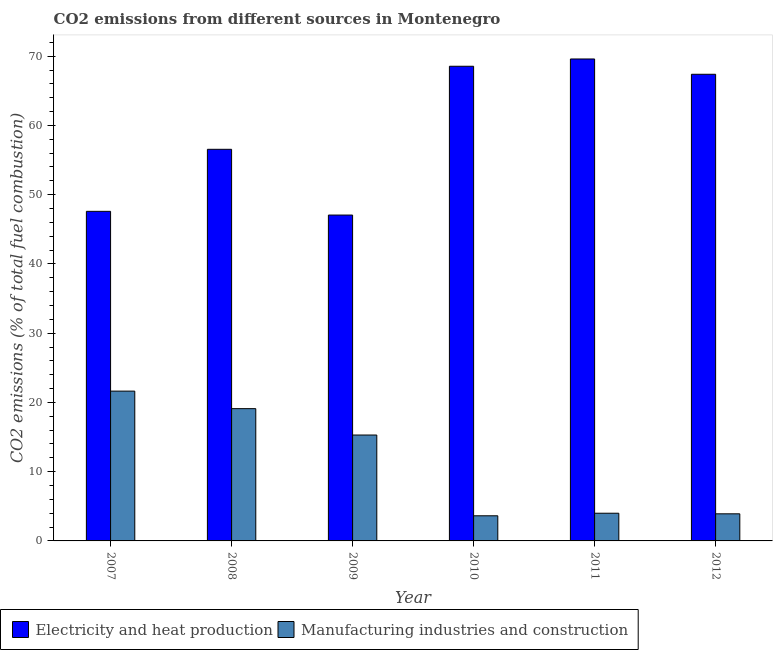How many different coloured bars are there?
Your answer should be compact. 2. How many groups of bars are there?
Provide a succinct answer. 6. What is the co2 emissions due to electricity and heat production in 2009?
Provide a short and direct response. 47.06. Across all years, what is the maximum co2 emissions due to electricity and heat production?
Give a very brief answer. 69.6. Across all years, what is the minimum co2 emissions due to manufacturing industries?
Offer a terse response. 3.63. In which year was the co2 emissions due to electricity and heat production minimum?
Your answer should be very brief. 2009. What is the total co2 emissions due to electricity and heat production in the graph?
Provide a short and direct response. 356.75. What is the difference between the co2 emissions due to electricity and heat production in 2008 and that in 2010?
Your response must be concise. -11.99. What is the difference between the co2 emissions due to manufacturing industries in 2012 and the co2 emissions due to electricity and heat production in 2007?
Give a very brief answer. -17.72. What is the average co2 emissions due to manufacturing industries per year?
Offer a very short reply. 11.26. What is the ratio of the co2 emissions due to manufacturing industries in 2010 to that in 2011?
Give a very brief answer. 0.91. Is the difference between the co2 emissions due to electricity and heat production in 2007 and 2010 greater than the difference between the co2 emissions due to manufacturing industries in 2007 and 2010?
Provide a succinct answer. No. What is the difference between the highest and the second highest co2 emissions due to electricity and heat production?
Make the answer very short. 1.05. What is the difference between the highest and the lowest co2 emissions due to manufacturing industries?
Ensure brevity in your answer.  18.01. In how many years, is the co2 emissions due to electricity and heat production greater than the average co2 emissions due to electricity and heat production taken over all years?
Offer a very short reply. 3. What does the 1st bar from the left in 2011 represents?
Provide a succinct answer. Electricity and heat production. What does the 2nd bar from the right in 2012 represents?
Your answer should be very brief. Electricity and heat production. How many years are there in the graph?
Your response must be concise. 6. What is the difference between two consecutive major ticks on the Y-axis?
Provide a short and direct response. 10. Does the graph contain any zero values?
Make the answer very short. No. Does the graph contain grids?
Offer a very short reply. No. What is the title of the graph?
Your answer should be compact. CO2 emissions from different sources in Montenegro. Does "Quality of trade" appear as one of the legend labels in the graph?
Give a very brief answer. No. What is the label or title of the Y-axis?
Ensure brevity in your answer.  CO2 emissions (% of total fuel combustion). What is the CO2 emissions (% of total fuel combustion) of Electricity and heat production in 2007?
Ensure brevity in your answer.  47.6. What is the CO2 emissions (% of total fuel combustion) of Manufacturing industries and construction in 2007?
Keep it short and to the point. 21.63. What is the CO2 emissions (% of total fuel combustion) in Electricity and heat production in 2008?
Make the answer very short. 56.55. What is the CO2 emissions (% of total fuel combustion) in Manufacturing industries and construction in 2008?
Provide a short and direct response. 19.1. What is the CO2 emissions (% of total fuel combustion) in Electricity and heat production in 2009?
Your answer should be very brief. 47.06. What is the CO2 emissions (% of total fuel combustion) of Manufacturing industries and construction in 2009?
Your answer should be compact. 15.29. What is the CO2 emissions (% of total fuel combustion) of Electricity and heat production in 2010?
Your answer should be very brief. 68.55. What is the CO2 emissions (% of total fuel combustion) of Manufacturing industries and construction in 2010?
Your answer should be very brief. 3.63. What is the CO2 emissions (% of total fuel combustion) in Electricity and heat production in 2011?
Your answer should be very brief. 69.6. What is the CO2 emissions (% of total fuel combustion) of Electricity and heat production in 2012?
Your response must be concise. 67.39. What is the CO2 emissions (% of total fuel combustion) in Manufacturing industries and construction in 2012?
Your answer should be compact. 3.91. Across all years, what is the maximum CO2 emissions (% of total fuel combustion) in Electricity and heat production?
Provide a succinct answer. 69.6. Across all years, what is the maximum CO2 emissions (% of total fuel combustion) of Manufacturing industries and construction?
Your answer should be compact. 21.63. Across all years, what is the minimum CO2 emissions (% of total fuel combustion) in Electricity and heat production?
Make the answer very short. 47.06. Across all years, what is the minimum CO2 emissions (% of total fuel combustion) of Manufacturing industries and construction?
Your answer should be compact. 3.63. What is the total CO2 emissions (% of total fuel combustion) of Electricity and heat production in the graph?
Your response must be concise. 356.75. What is the total CO2 emissions (% of total fuel combustion) of Manufacturing industries and construction in the graph?
Give a very brief answer. 67.57. What is the difference between the CO2 emissions (% of total fuel combustion) in Electricity and heat production in 2007 and that in 2008?
Provide a succinct answer. -8.96. What is the difference between the CO2 emissions (% of total fuel combustion) of Manufacturing industries and construction in 2007 and that in 2008?
Your answer should be compact. 2.53. What is the difference between the CO2 emissions (% of total fuel combustion) of Electricity and heat production in 2007 and that in 2009?
Make the answer very short. 0.54. What is the difference between the CO2 emissions (% of total fuel combustion) of Manufacturing industries and construction in 2007 and that in 2009?
Keep it short and to the point. 6.34. What is the difference between the CO2 emissions (% of total fuel combustion) in Electricity and heat production in 2007 and that in 2010?
Provide a short and direct response. -20.95. What is the difference between the CO2 emissions (% of total fuel combustion) of Manufacturing industries and construction in 2007 and that in 2010?
Your response must be concise. 18.01. What is the difference between the CO2 emissions (% of total fuel combustion) of Electricity and heat production in 2007 and that in 2011?
Offer a very short reply. -22. What is the difference between the CO2 emissions (% of total fuel combustion) of Manufacturing industries and construction in 2007 and that in 2011?
Make the answer very short. 17.63. What is the difference between the CO2 emissions (% of total fuel combustion) of Electricity and heat production in 2007 and that in 2012?
Your response must be concise. -19.8. What is the difference between the CO2 emissions (% of total fuel combustion) of Manufacturing industries and construction in 2007 and that in 2012?
Provide a succinct answer. 17.72. What is the difference between the CO2 emissions (% of total fuel combustion) in Electricity and heat production in 2008 and that in 2009?
Offer a terse response. 9.5. What is the difference between the CO2 emissions (% of total fuel combustion) in Manufacturing industries and construction in 2008 and that in 2009?
Your response must be concise. 3.81. What is the difference between the CO2 emissions (% of total fuel combustion) of Electricity and heat production in 2008 and that in 2010?
Your response must be concise. -11.99. What is the difference between the CO2 emissions (% of total fuel combustion) of Manufacturing industries and construction in 2008 and that in 2010?
Offer a terse response. 15.47. What is the difference between the CO2 emissions (% of total fuel combustion) of Electricity and heat production in 2008 and that in 2011?
Your answer should be very brief. -13.05. What is the difference between the CO2 emissions (% of total fuel combustion) in Manufacturing industries and construction in 2008 and that in 2011?
Offer a very short reply. 15.1. What is the difference between the CO2 emissions (% of total fuel combustion) in Electricity and heat production in 2008 and that in 2012?
Your answer should be very brief. -10.84. What is the difference between the CO2 emissions (% of total fuel combustion) in Manufacturing industries and construction in 2008 and that in 2012?
Offer a terse response. 15.19. What is the difference between the CO2 emissions (% of total fuel combustion) in Electricity and heat production in 2009 and that in 2010?
Offer a very short reply. -21.49. What is the difference between the CO2 emissions (% of total fuel combustion) of Manufacturing industries and construction in 2009 and that in 2010?
Offer a terse response. 11.67. What is the difference between the CO2 emissions (% of total fuel combustion) in Electricity and heat production in 2009 and that in 2011?
Give a very brief answer. -22.54. What is the difference between the CO2 emissions (% of total fuel combustion) of Manufacturing industries and construction in 2009 and that in 2011?
Your response must be concise. 11.29. What is the difference between the CO2 emissions (% of total fuel combustion) in Electricity and heat production in 2009 and that in 2012?
Provide a short and direct response. -20.33. What is the difference between the CO2 emissions (% of total fuel combustion) in Manufacturing industries and construction in 2009 and that in 2012?
Provide a short and direct response. 11.38. What is the difference between the CO2 emissions (% of total fuel combustion) of Electricity and heat production in 2010 and that in 2011?
Offer a terse response. -1.05. What is the difference between the CO2 emissions (% of total fuel combustion) in Manufacturing industries and construction in 2010 and that in 2011?
Your response must be concise. -0.37. What is the difference between the CO2 emissions (% of total fuel combustion) in Electricity and heat production in 2010 and that in 2012?
Your response must be concise. 1.16. What is the difference between the CO2 emissions (% of total fuel combustion) of Manufacturing industries and construction in 2010 and that in 2012?
Offer a very short reply. -0.28. What is the difference between the CO2 emissions (% of total fuel combustion) in Electricity and heat production in 2011 and that in 2012?
Make the answer very short. 2.21. What is the difference between the CO2 emissions (% of total fuel combustion) of Manufacturing industries and construction in 2011 and that in 2012?
Provide a succinct answer. 0.09. What is the difference between the CO2 emissions (% of total fuel combustion) of Electricity and heat production in 2007 and the CO2 emissions (% of total fuel combustion) of Manufacturing industries and construction in 2008?
Your answer should be compact. 28.5. What is the difference between the CO2 emissions (% of total fuel combustion) of Electricity and heat production in 2007 and the CO2 emissions (% of total fuel combustion) of Manufacturing industries and construction in 2009?
Your response must be concise. 32.3. What is the difference between the CO2 emissions (% of total fuel combustion) of Electricity and heat production in 2007 and the CO2 emissions (% of total fuel combustion) of Manufacturing industries and construction in 2010?
Your answer should be compact. 43.97. What is the difference between the CO2 emissions (% of total fuel combustion) in Electricity and heat production in 2007 and the CO2 emissions (% of total fuel combustion) in Manufacturing industries and construction in 2011?
Your answer should be very brief. 43.6. What is the difference between the CO2 emissions (% of total fuel combustion) of Electricity and heat production in 2007 and the CO2 emissions (% of total fuel combustion) of Manufacturing industries and construction in 2012?
Your response must be concise. 43.68. What is the difference between the CO2 emissions (% of total fuel combustion) of Electricity and heat production in 2008 and the CO2 emissions (% of total fuel combustion) of Manufacturing industries and construction in 2009?
Ensure brevity in your answer.  41.26. What is the difference between the CO2 emissions (% of total fuel combustion) of Electricity and heat production in 2008 and the CO2 emissions (% of total fuel combustion) of Manufacturing industries and construction in 2010?
Your response must be concise. 52.93. What is the difference between the CO2 emissions (% of total fuel combustion) in Electricity and heat production in 2008 and the CO2 emissions (% of total fuel combustion) in Manufacturing industries and construction in 2011?
Provide a succinct answer. 52.55. What is the difference between the CO2 emissions (% of total fuel combustion) of Electricity and heat production in 2008 and the CO2 emissions (% of total fuel combustion) of Manufacturing industries and construction in 2012?
Provide a short and direct response. 52.64. What is the difference between the CO2 emissions (% of total fuel combustion) of Electricity and heat production in 2009 and the CO2 emissions (% of total fuel combustion) of Manufacturing industries and construction in 2010?
Offer a very short reply. 43.43. What is the difference between the CO2 emissions (% of total fuel combustion) in Electricity and heat production in 2009 and the CO2 emissions (% of total fuel combustion) in Manufacturing industries and construction in 2011?
Your response must be concise. 43.06. What is the difference between the CO2 emissions (% of total fuel combustion) of Electricity and heat production in 2009 and the CO2 emissions (% of total fuel combustion) of Manufacturing industries and construction in 2012?
Provide a succinct answer. 43.15. What is the difference between the CO2 emissions (% of total fuel combustion) in Electricity and heat production in 2010 and the CO2 emissions (% of total fuel combustion) in Manufacturing industries and construction in 2011?
Provide a short and direct response. 64.55. What is the difference between the CO2 emissions (% of total fuel combustion) in Electricity and heat production in 2010 and the CO2 emissions (% of total fuel combustion) in Manufacturing industries and construction in 2012?
Your answer should be very brief. 64.64. What is the difference between the CO2 emissions (% of total fuel combustion) of Electricity and heat production in 2011 and the CO2 emissions (% of total fuel combustion) of Manufacturing industries and construction in 2012?
Give a very brief answer. 65.69. What is the average CO2 emissions (% of total fuel combustion) in Electricity and heat production per year?
Your answer should be compact. 59.46. What is the average CO2 emissions (% of total fuel combustion) of Manufacturing industries and construction per year?
Your answer should be very brief. 11.26. In the year 2007, what is the difference between the CO2 emissions (% of total fuel combustion) of Electricity and heat production and CO2 emissions (% of total fuel combustion) of Manufacturing industries and construction?
Provide a succinct answer. 25.96. In the year 2008, what is the difference between the CO2 emissions (% of total fuel combustion) in Electricity and heat production and CO2 emissions (% of total fuel combustion) in Manufacturing industries and construction?
Keep it short and to the point. 37.45. In the year 2009, what is the difference between the CO2 emissions (% of total fuel combustion) of Electricity and heat production and CO2 emissions (% of total fuel combustion) of Manufacturing industries and construction?
Your answer should be compact. 31.76. In the year 2010, what is the difference between the CO2 emissions (% of total fuel combustion) of Electricity and heat production and CO2 emissions (% of total fuel combustion) of Manufacturing industries and construction?
Make the answer very short. 64.92. In the year 2011, what is the difference between the CO2 emissions (% of total fuel combustion) in Electricity and heat production and CO2 emissions (% of total fuel combustion) in Manufacturing industries and construction?
Make the answer very short. 65.6. In the year 2012, what is the difference between the CO2 emissions (% of total fuel combustion) of Electricity and heat production and CO2 emissions (% of total fuel combustion) of Manufacturing industries and construction?
Provide a succinct answer. 63.48. What is the ratio of the CO2 emissions (% of total fuel combustion) of Electricity and heat production in 2007 to that in 2008?
Your answer should be compact. 0.84. What is the ratio of the CO2 emissions (% of total fuel combustion) in Manufacturing industries and construction in 2007 to that in 2008?
Provide a short and direct response. 1.13. What is the ratio of the CO2 emissions (% of total fuel combustion) in Electricity and heat production in 2007 to that in 2009?
Offer a terse response. 1.01. What is the ratio of the CO2 emissions (% of total fuel combustion) in Manufacturing industries and construction in 2007 to that in 2009?
Offer a very short reply. 1.41. What is the ratio of the CO2 emissions (% of total fuel combustion) in Electricity and heat production in 2007 to that in 2010?
Keep it short and to the point. 0.69. What is the ratio of the CO2 emissions (% of total fuel combustion) in Manufacturing industries and construction in 2007 to that in 2010?
Ensure brevity in your answer.  5.96. What is the ratio of the CO2 emissions (% of total fuel combustion) in Electricity and heat production in 2007 to that in 2011?
Your response must be concise. 0.68. What is the ratio of the CO2 emissions (% of total fuel combustion) of Manufacturing industries and construction in 2007 to that in 2011?
Make the answer very short. 5.41. What is the ratio of the CO2 emissions (% of total fuel combustion) of Electricity and heat production in 2007 to that in 2012?
Make the answer very short. 0.71. What is the ratio of the CO2 emissions (% of total fuel combustion) in Manufacturing industries and construction in 2007 to that in 2012?
Keep it short and to the point. 5.53. What is the ratio of the CO2 emissions (% of total fuel combustion) in Electricity and heat production in 2008 to that in 2009?
Your answer should be very brief. 1.2. What is the ratio of the CO2 emissions (% of total fuel combustion) in Manufacturing industries and construction in 2008 to that in 2009?
Your answer should be very brief. 1.25. What is the ratio of the CO2 emissions (% of total fuel combustion) of Electricity and heat production in 2008 to that in 2010?
Make the answer very short. 0.82. What is the ratio of the CO2 emissions (% of total fuel combustion) in Manufacturing industries and construction in 2008 to that in 2010?
Your answer should be very brief. 5.26. What is the ratio of the CO2 emissions (% of total fuel combustion) in Electricity and heat production in 2008 to that in 2011?
Provide a succinct answer. 0.81. What is the ratio of the CO2 emissions (% of total fuel combustion) in Manufacturing industries and construction in 2008 to that in 2011?
Offer a terse response. 4.78. What is the ratio of the CO2 emissions (% of total fuel combustion) of Electricity and heat production in 2008 to that in 2012?
Offer a terse response. 0.84. What is the ratio of the CO2 emissions (% of total fuel combustion) of Manufacturing industries and construction in 2008 to that in 2012?
Your answer should be compact. 4.88. What is the ratio of the CO2 emissions (% of total fuel combustion) in Electricity and heat production in 2009 to that in 2010?
Your answer should be compact. 0.69. What is the ratio of the CO2 emissions (% of total fuel combustion) of Manufacturing industries and construction in 2009 to that in 2010?
Ensure brevity in your answer.  4.21. What is the ratio of the CO2 emissions (% of total fuel combustion) of Electricity and heat production in 2009 to that in 2011?
Give a very brief answer. 0.68. What is the ratio of the CO2 emissions (% of total fuel combustion) of Manufacturing industries and construction in 2009 to that in 2011?
Your answer should be compact. 3.82. What is the ratio of the CO2 emissions (% of total fuel combustion) in Electricity and heat production in 2009 to that in 2012?
Provide a short and direct response. 0.7. What is the ratio of the CO2 emissions (% of total fuel combustion) in Manufacturing industries and construction in 2009 to that in 2012?
Give a very brief answer. 3.91. What is the ratio of the CO2 emissions (% of total fuel combustion) of Electricity and heat production in 2010 to that in 2011?
Offer a very short reply. 0.98. What is the ratio of the CO2 emissions (% of total fuel combustion) in Manufacturing industries and construction in 2010 to that in 2011?
Ensure brevity in your answer.  0.91. What is the ratio of the CO2 emissions (% of total fuel combustion) of Electricity and heat production in 2010 to that in 2012?
Make the answer very short. 1.02. What is the ratio of the CO2 emissions (% of total fuel combustion) in Manufacturing industries and construction in 2010 to that in 2012?
Ensure brevity in your answer.  0.93. What is the ratio of the CO2 emissions (% of total fuel combustion) in Electricity and heat production in 2011 to that in 2012?
Offer a very short reply. 1.03. What is the ratio of the CO2 emissions (% of total fuel combustion) in Manufacturing industries and construction in 2011 to that in 2012?
Ensure brevity in your answer.  1.02. What is the difference between the highest and the second highest CO2 emissions (% of total fuel combustion) in Electricity and heat production?
Ensure brevity in your answer.  1.05. What is the difference between the highest and the second highest CO2 emissions (% of total fuel combustion) of Manufacturing industries and construction?
Provide a short and direct response. 2.53. What is the difference between the highest and the lowest CO2 emissions (% of total fuel combustion) of Electricity and heat production?
Provide a short and direct response. 22.54. What is the difference between the highest and the lowest CO2 emissions (% of total fuel combustion) in Manufacturing industries and construction?
Offer a very short reply. 18.01. 